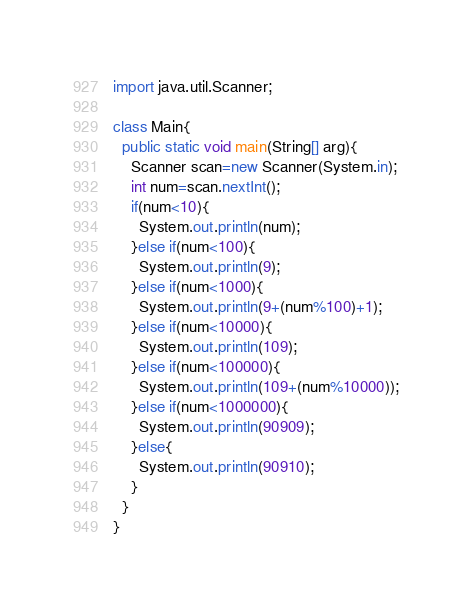<code> <loc_0><loc_0><loc_500><loc_500><_Java_>import java.util.Scanner;

class Main{
  public static void main(String[] arg){
    Scanner scan=new Scanner(System.in);
    int num=scan.nextInt();
    if(num<10){
      System.out.println(num);
    }else if(num<100){
      System.out.println(9);
    }else if(num<1000){
      System.out.println(9+(num%100)+1);
    }else if(num<10000){
      System.out.println(109);
    }else if(num<100000){
      System.out.println(109+(num%10000));
    }else if(num<1000000){
      System.out.println(90909);
    }else{
      System.out.println(90910);
    }
  }
}</code> 